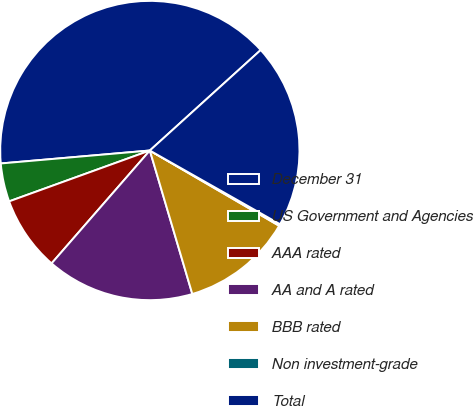Convert chart to OTSL. <chart><loc_0><loc_0><loc_500><loc_500><pie_chart><fcel>December 31<fcel>US Government and Agencies<fcel>AAA rated<fcel>AA and A rated<fcel>BBB rated<fcel>Non investment-grade<fcel>Total<nl><fcel>39.66%<fcel>4.14%<fcel>8.08%<fcel>15.98%<fcel>12.03%<fcel>0.19%<fcel>19.92%<nl></chart> 